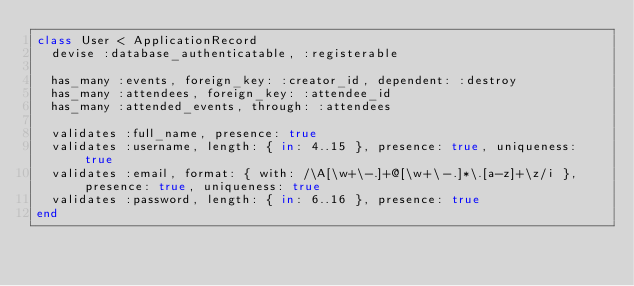<code> <loc_0><loc_0><loc_500><loc_500><_Ruby_>class User < ApplicationRecord
  devise :database_authenticatable, :registerable

  has_many :events, foreign_key: :creator_id, dependent: :destroy
  has_many :attendees, foreign_key: :attendee_id
  has_many :attended_events, through: :attendees

  validates :full_name, presence: true
  validates :username, length: { in: 4..15 }, presence: true, uniqueness: true
  validates :email, format: { with: /\A[\w+\-.]+@[\w+\-.]*\.[a-z]+\z/i }, presence: true, uniqueness: true
  validates :password, length: { in: 6..16 }, presence: true
end
</code> 